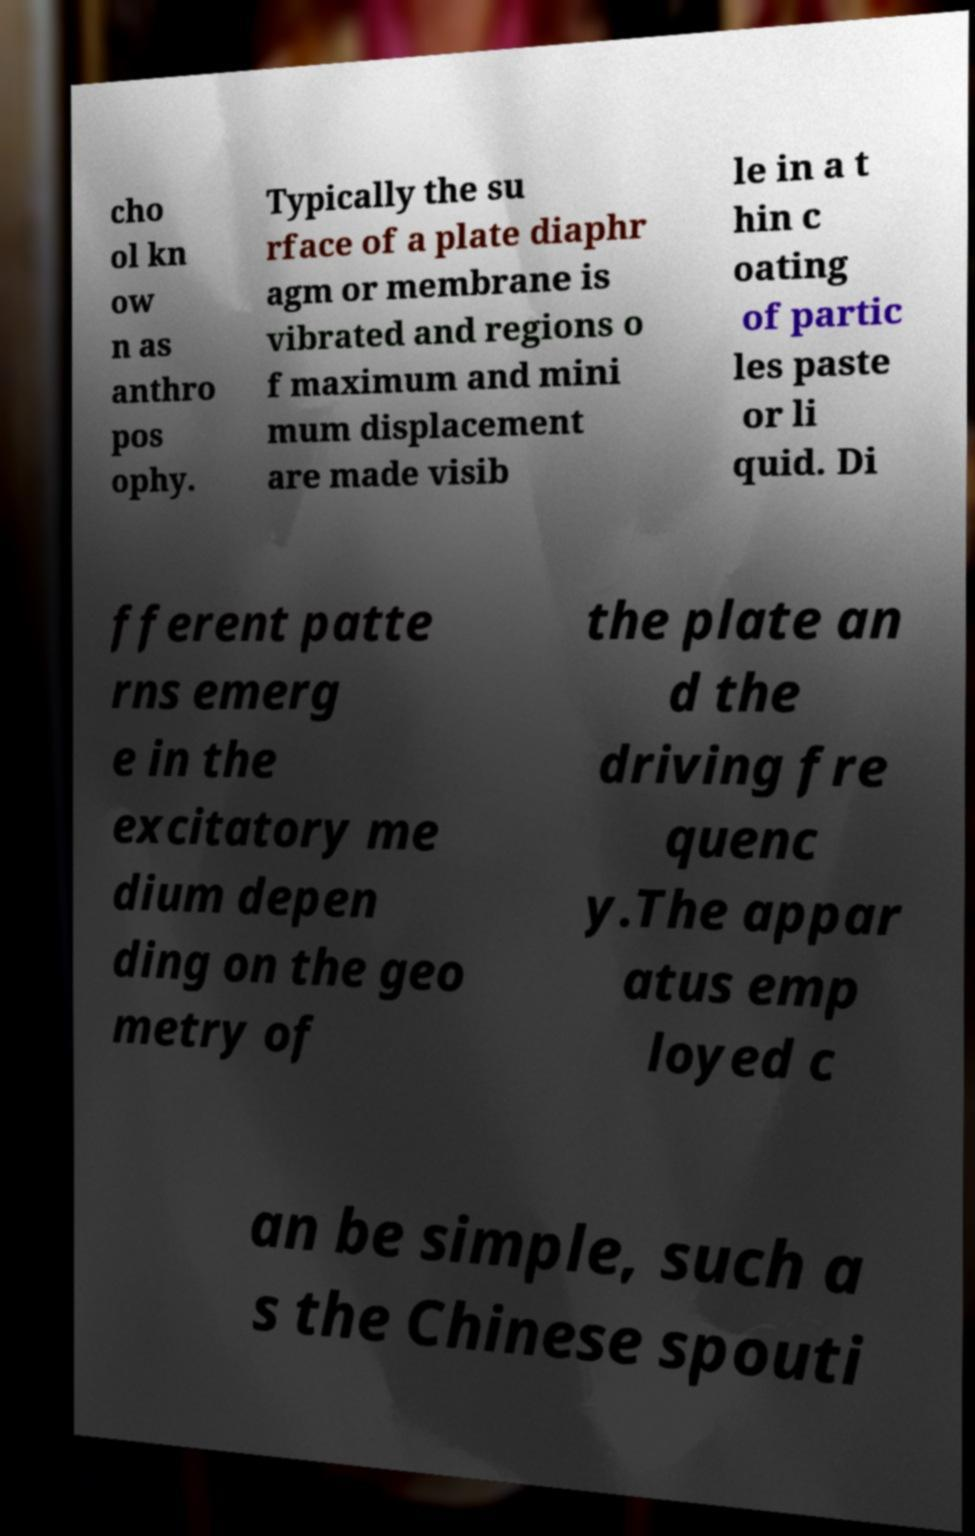Could you assist in decoding the text presented in this image and type it out clearly? cho ol kn ow n as anthro pos ophy. Typically the su rface of a plate diaphr agm or membrane is vibrated and regions o f maximum and mini mum displacement are made visib le in a t hin c oating of partic les paste or li quid. Di fferent patte rns emerg e in the excitatory me dium depen ding on the geo metry of the plate an d the driving fre quenc y.The appar atus emp loyed c an be simple, such a s the Chinese spouti 